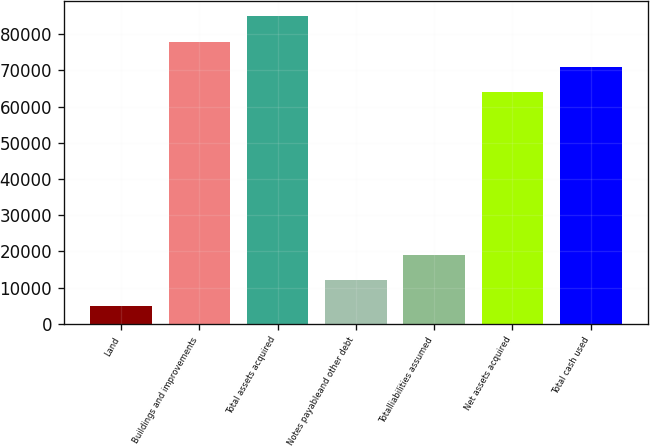<chart> <loc_0><loc_0><loc_500><loc_500><bar_chart><fcel>Land<fcel>Buildings and improvements<fcel>Total assets acquired<fcel>Notes payableand other debt<fcel>Totalliabilities assumed<fcel>Net assets acquired<fcel>Total cash used<nl><fcel>5016<fcel>77943.8<fcel>84926.2<fcel>11998.4<fcel>18980.8<fcel>63979<fcel>70961.4<nl></chart> 